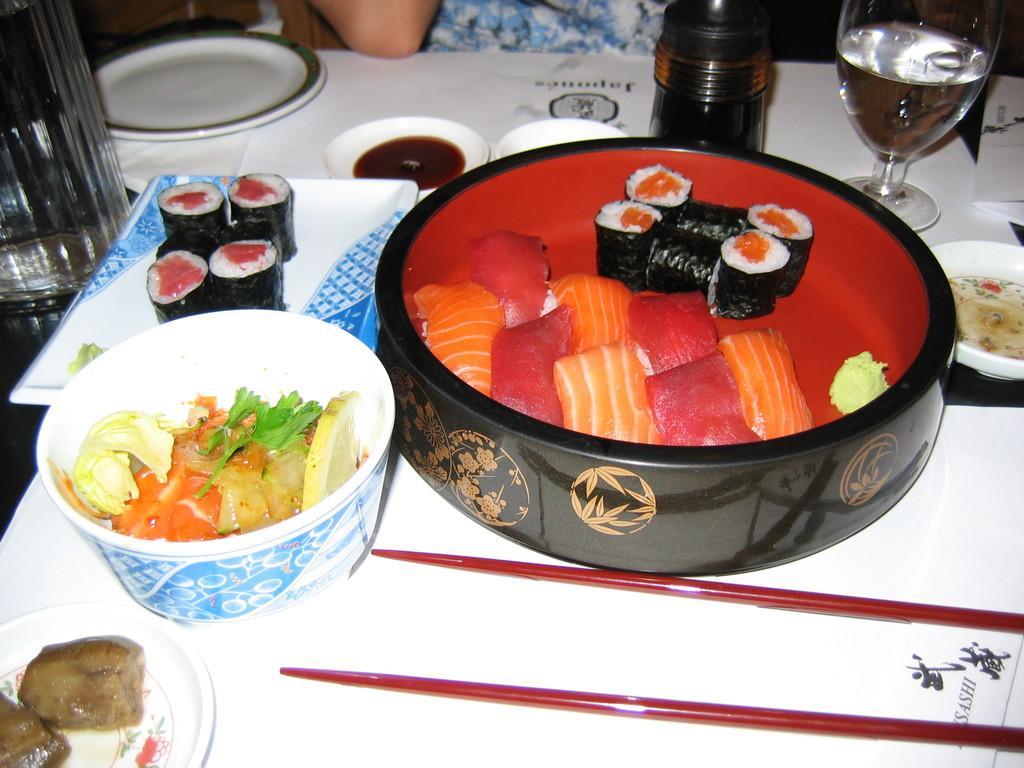Can you describe this image briefly? These are the food items. And it's a glass. 